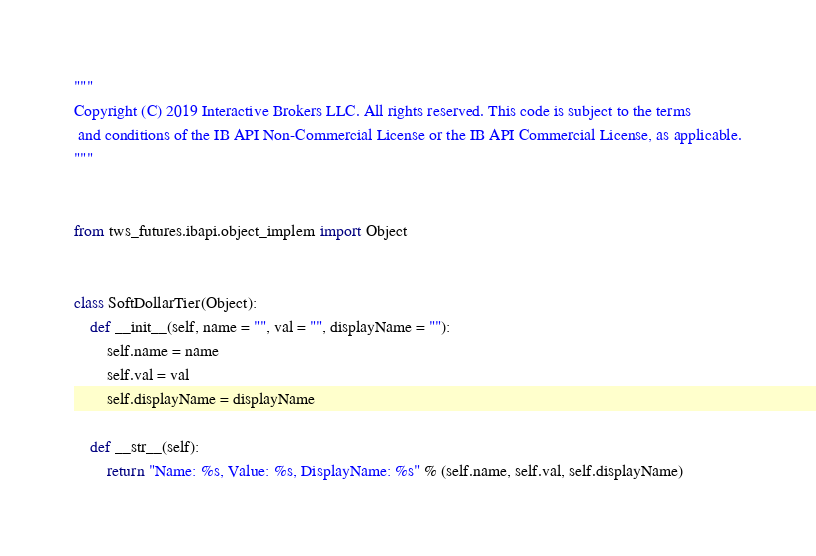<code> <loc_0><loc_0><loc_500><loc_500><_Python_>"""
Copyright (C) 2019 Interactive Brokers LLC. All rights reserved. This code is subject to the terms
 and conditions of the IB API Non-Commercial License or the IB API Commercial License, as applicable.
"""


from tws_futures.ibapi.object_implem import Object

 
class SoftDollarTier(Object):
    def __init__(self, name = "", val = "", displayName = ""):
        self.name = name
        self.val = val
        self.displayName = displayName

    def __str__(self):
        return "Name: %s, Value: %s, DisplayName: %s" % (self.name, self.val, self.displayName)
</code> 